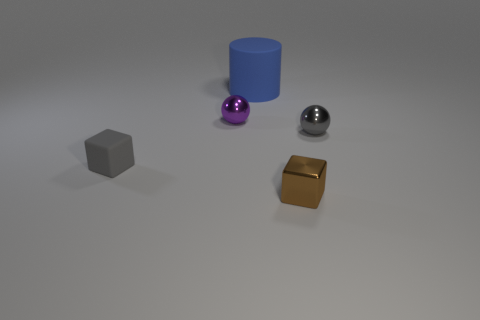How is the lighting in the image affecting the appearance of the objects? The lighting in the image is soft and seems to be coming from above and to the left, casting gentle shadows to the right of the objects. The light highlights the textures of the objects, enhancing the sheen on the metallic ball and golden cube, in contrast to the matte surfaces of the other objects, which scatter the light more diffusely. 